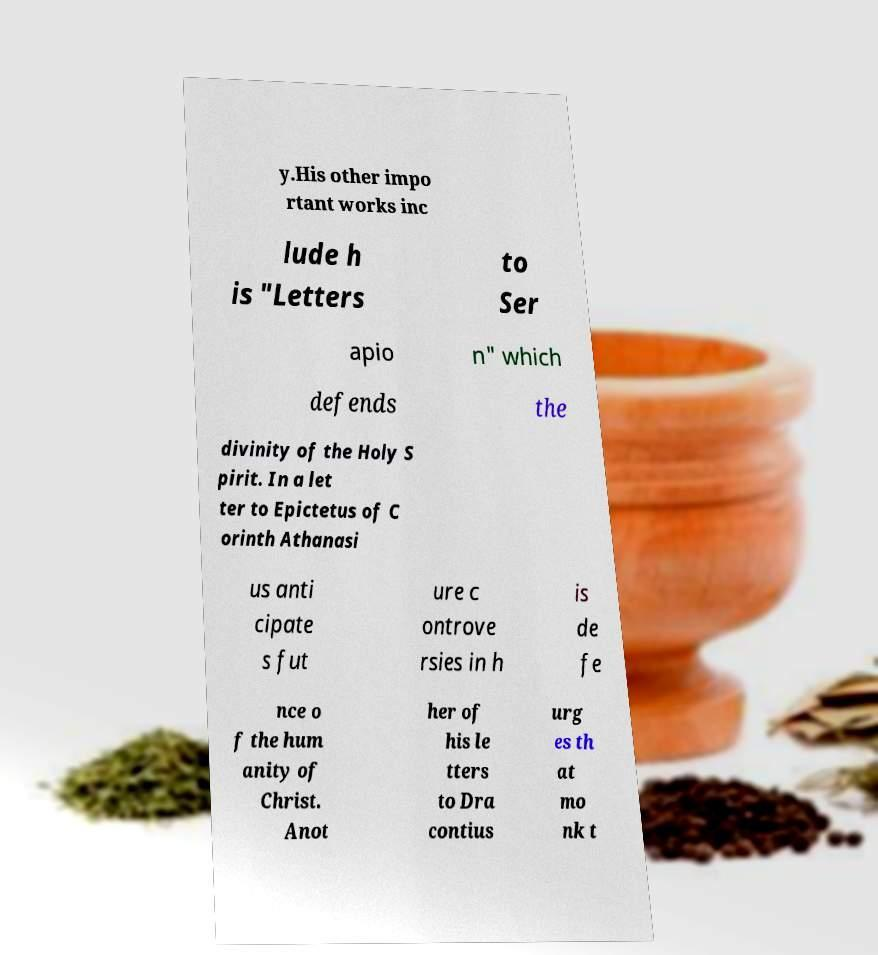Could you assist in decoding the text presented in this image and type it out clearly? y.His other impo rtant works inc lude h is "Letters to Ser apio n" which defends the divinity of the Holy S pirit. In a let ter to Epictetus of C orinth Athanasi us anti cipate s fut ure c ontrove rsies in h is de fe nce o f the hum anity of Christ. Anot her of his le tters to Dra contius urg es th at mo nk t 